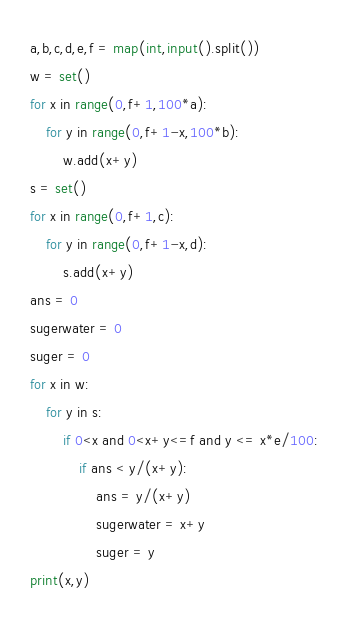<code> <loc_0><loc_0><loc_500><loc_500><_Python_>a,b,c,d,e,f = map(int,input().split())
w = set()
for x in range(0,f+1,100*a):
    for y in range(0,f+1-x,100*b):
        w.add(x+y)
s = set()
for x in range(0,f+1,c):
    for y in range(0,f+1-x,d):
        s.add(x+y)
ans = 0
sugerwater = 0
suger = 0
for x in w:
    for y in s:
        if 0<x and 0<x+y<=f and y <= x*e/100:
            if ans < y/(x+y):
                ans = y/(x+y)
                sugerwater = x+y
                suger = y
print(x,y)
</code> 